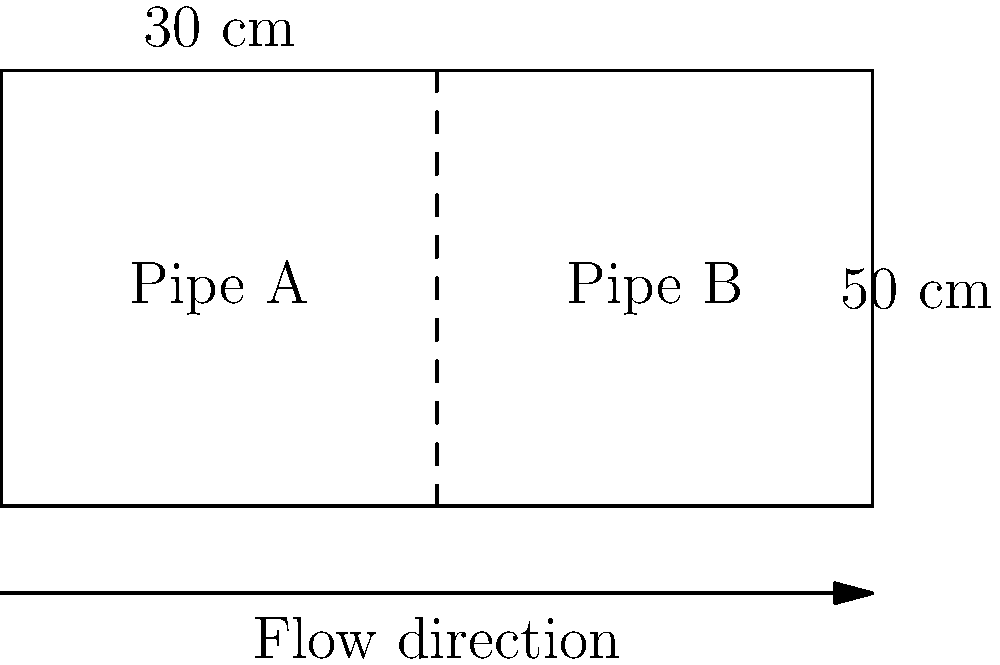As a medical device manufacturer interested in optimizing fluid flow systems, consider the following scenario: Water flows through two connected pipes with different diameters, as shown in the diagram. Pipe A has a diameter of 30 cm, and Pipe B has a diameter of 50 cm. If the flow rate in Pipe A is 100 L/s, what is the flow rate in Pipe B? To solve this problem, we'll use the principle of continuity, which states that the volume flow rate remains constant throughout a closed system. This principle is crucial in designing efficient fluid delivery systems for medical devices.

Step 1: Define the continuity equation
$$ Q_1 = Q_2 $$
Where $Q_1$ is the flow rate in Pipe A and $Q_2$ is the flow rate in Pipe B.

Step 2: Express flow rate in terms of velocity and area
$$ A_1v_1 = A_2v_2 $$
Where $A$ is the cross-sectional area of the pipe and $v$ is the velocity of the fluid.

Step 3: Calculate the areas of the pipes
$A_1 = \pi r_1^2 = \pi (15\text{ cm})^2 = 706.86\text{ cm}^2$
$A_2 = \pi r_2^2 = \pi (25\text{ cm})^2 = 1963.50\text{ cm}^2$

Step 4: Calculate the velocity in Pipe A
$v_1 = \frac{Q_1}{A_1} = \frac{100\text{ L/s}}{706.86\text{ cm}^2} = 0.1415\text{ m/s}$

Step 5: Use the continuity equation to find the velocity in Pipe B
$706.86\text{ cm}^2 \times 0.1415\text{ m/s} = 1963.50\text{ cm}^2 \times v_2$
$v_2 = 0.0509\text{ m/s}$

Step 6: Calculate the flow rate in Pipe B
$Q_2 = A_2v_2 = 1963.50\text{ cm}^2 \times 0.0509\text{ m/s} = 100\text{ L/s}$

This result demonstrates that the flow rate remains constant throughout the system, which is a key principle in designing efficient fluid delivery systems for medical devices.
Answer: 100 L/s 